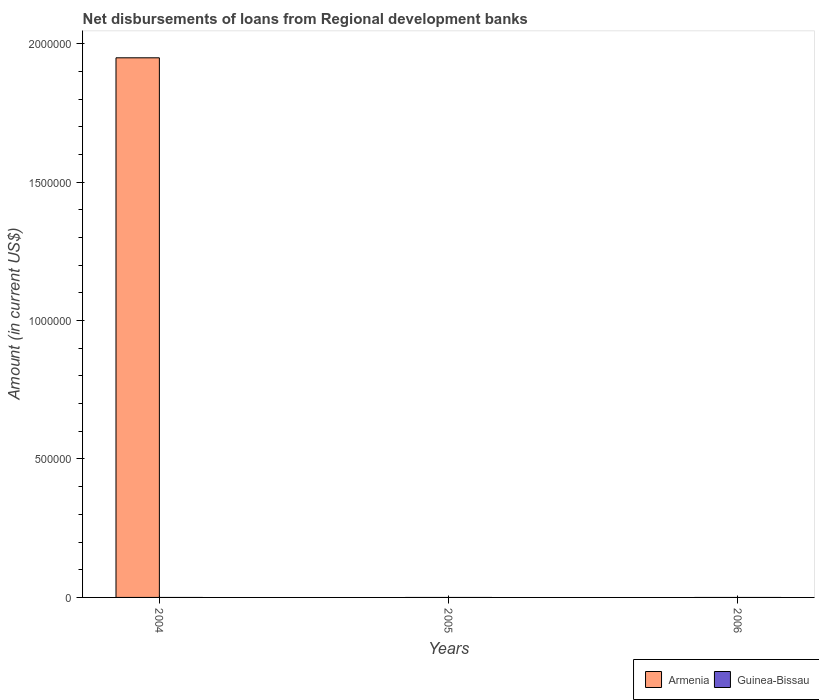How many different coloured bars are there?
Your response must be concise. 1. Are the number of bars per tick equal to the number of legend labels?
Offer a very short reply. No. Are the number of bars on each tick of the X-axis equal?
Provide a short and direct response. No. How many bars are there on the 3rd tick from the left?
Make the answer very short. 0. What is the label of the 3rd group of bars from the left?
Offer a terse response. 2006. In how many cases, is the number of bars for a given year not equal to the number of legend labels?
Provide a short and direct response. 3. What is the amount of disbursements of loans from regional development banks in Guinea-Bissau in 2005?
Make the answer very short. 0. Across all years, what is the maximum amount of disbursements of loans from regional development banks in Armenia?
Provide a succinct answer. 1.95e+06. Across all years, what is the minimum amount of disbursements of loans from regional development banks in Armenia?
Your answer should be compact. 0. What is the difference between the amount of disbursements of loans from regional development banks in Guinea-Bissau in 2005 and the amount of disbursements of loans from regional development banks in Armenia in 2004?
Keep it short and to the point. -1.95e+06. What is the difference between the highest and the lowest amount of disbursements of loans from regional development banks in Armenia?
Provide a succinct answer. 1.95e+06. What is the difference between two consecutive major ticks on the Y-axis?
Offer a terse response. 5.00e+05. Does the graph contain any zero values?
Give a very brief answer. Yes. Where does the legend appear in the graph?
Offer a terse response. Bottom right. How are the legend labels stacked?
Your answer should be very brief. Horizontal. What is the title of the graph?
Make the answer very short. Net disbursements of loans from Regional development banks. Does "Argentina" appear as one of the legend labels in the graph?
Provide a short and direct response. No. What is the Amount (in current US$) of Armenia in 2004?
Offer a terse response. 1.95e+06. What is the Amount (in current US$) of Armenia in 2005?
Ensure brevity in your answer.  0. What is the Amount (in current US$) in Armenia in 2006?
Offer a very short reply. 0. Across all years, what is the maximum Amount (in current US$) of Armenia?
Make the answer very short. 1.95e+06. What is the total Amount (in current US$) of Armenia in the graph?
Offer a terse response. 1.95e+06. What is the average Amount (in current US$) in Armenia per year?
Give a very brief answer. 6.50e+05. What is the difference between the highest and the lowest Amount (in current US$) of Armenia?
Provide a short and direct response. 1.95e+06. 